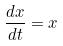<formula> <loc_0><loc_0><loc_500><loc_500>\frac { d x } { d t } = x</formula> 